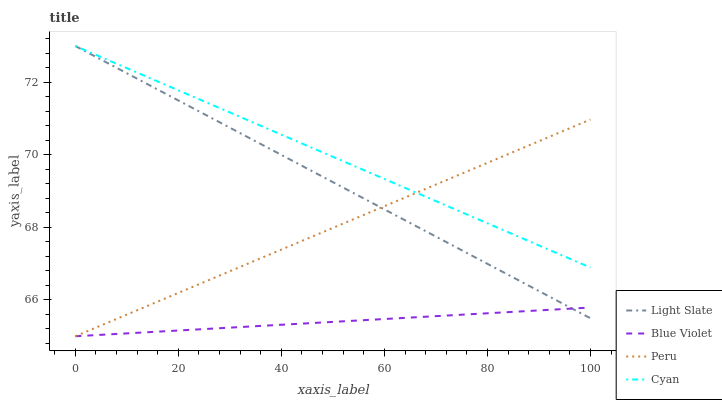Does Blue Violet have the minimum area under the curve?
Answer yes or no. Yes. Does Cyan have the maximum area under the curve?
Answer yes or no. Yes. Does Peru have the minimum area under the curve?
Answer yes or no. No. Does Peru have the maximum area under the curve?
Answer yes or no. No. Is Cyan the smoothest?
Answer yes or no. Yes. Is Blue Violet the roughest?
Answer yes or no. Yes. Is Peru the smoothest?
Answer yes or no. No. Is Peru the roughest?
Answer yes or no. No. Does Peru have the lowest value?
Answer yes or no. Yes. Does Cyan have the lowest value?
Answer yes or no. No. Does Cyan have the highest value?
Answer yes or no. Yes. Does Peru have the highest value?
Answer yes or no. No. Is Blue Violet less than Cyan?
Answer yes or no. Yes. Is Cyan greater than Blue Violet?
Answer yes or no. Yes. Does Peru intersect Blue Violet?
Answer yes or no. Yes. Is Peru less than Blue Violet?
Answer yes or no. No. Is Peru greater than Blue Violet?
Answer yes or no. No. Does Blue Violet intersect Cyan?
Answer yes or no. No. 